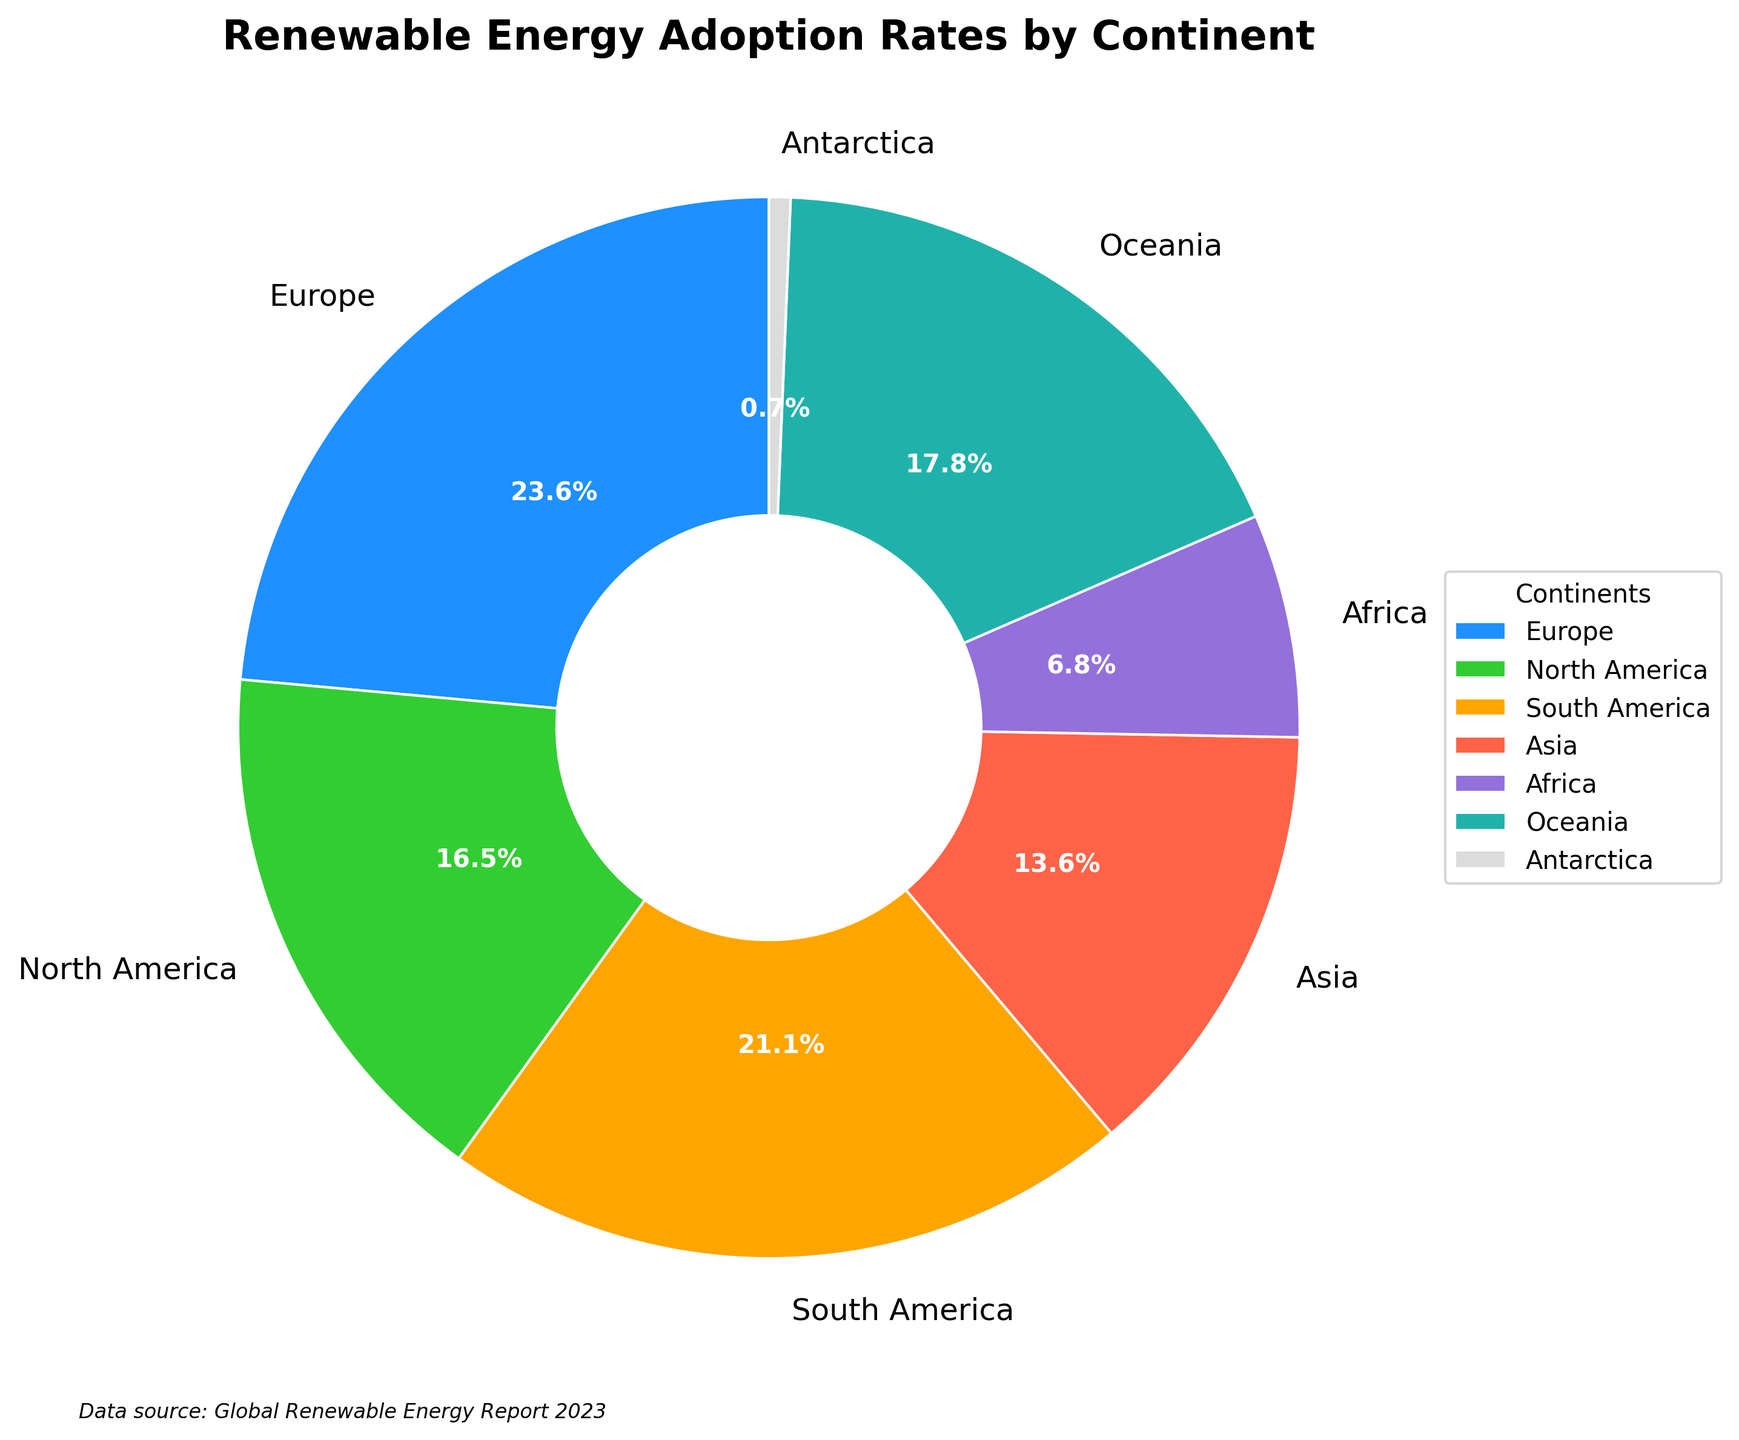What continent has the highest renewable energy adoption rate? The pie chart shows the renewable energy adoption rates by continent. Europe has the largest slice at 32.5%, which is the highest rate.
Answer: Europe What continent has the lowest renewable energy adoption rate? By looking at the pie chart, Antarctica has the smallest slice at 0.9%, indicating the lowest renewable energy adoption rate.
Answer: Antarctica Which continents have renewable energy adoption rates greater than 20%? From the pie chart, the slices indicating Europe (32.5%), South America (29.1%), North America (22.8%), and Oceania (24.6%) are all greater than 20%.
Answer: Europe, South America, North America, Oceania What is the difference in renewable energy adoption rates between Europe and Asia? Europe's adoption rate is 32.5%, and Asia's rate is 18.7%. By subtracting Asia's rate from Europe's rate (32.5% - 18.7%), the difference is 13.8%.
Answer: 13.8% What is the combined renewable energy adoption rate for Europe and South America? Adding the rates for Europe (32.5%) and South America (29.1%) results in a combined rate of 32.5% + 29.1% = 61.6%.
Answer: 61.6% How does the renewable energy adoption rate of Oceania compare to North America? Oceania's adoption rate is 24.6%, while North America's rate is 22.8%. Oceania has a higher rate by 24.6% - 22.8% = 1.8%.
Answer: Oceania has a higher rate by 1.8% What is the average renewable energy adoption rate for the continents except Antarctica? Excluding Antarctica, the rates are: Europe (32.5%), North America (22.8%), South America (29.1%), Asia (18.7%), Africa (9.4%), and Oceania (24.6%). Adding these rates and dividing by 6 gives (32.5 + 22.8 + 29.1 + 18.7 + 9.4 + 24.6) / 6 = 22.85%.
Answer: 22.85% Which continent has a slice colored with a shade of green? The pie chart uses custom colors, and North America's slice is in a shade of green with a 22.8% rate.
Answer: North America 